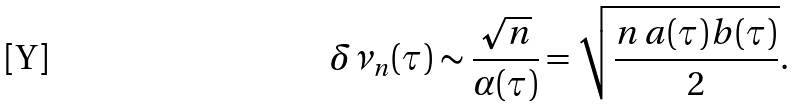Convert formula to latex. <formula><loc_0><loc_0><loc_500><loc_500>\delta \nu _ { n } ( \tau ) \sim \frac { \sqrt { n } } { \alpha ( \tau ) } = \sqrt { \frac { n \, a ( \tau ) b ( \tau ) } { 2 } } .</formula> 